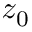<formula> <loc_0><loc_0><loc_500><loc_500>z _ { 0 }</formula> 